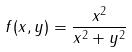<formula> <loc_0><loc_0><loc_500><loc_500>f ( x , y ) = \frac { x ^ { 2 } } { x ^ { 2 } + y ^ { 2 } }</formula> 